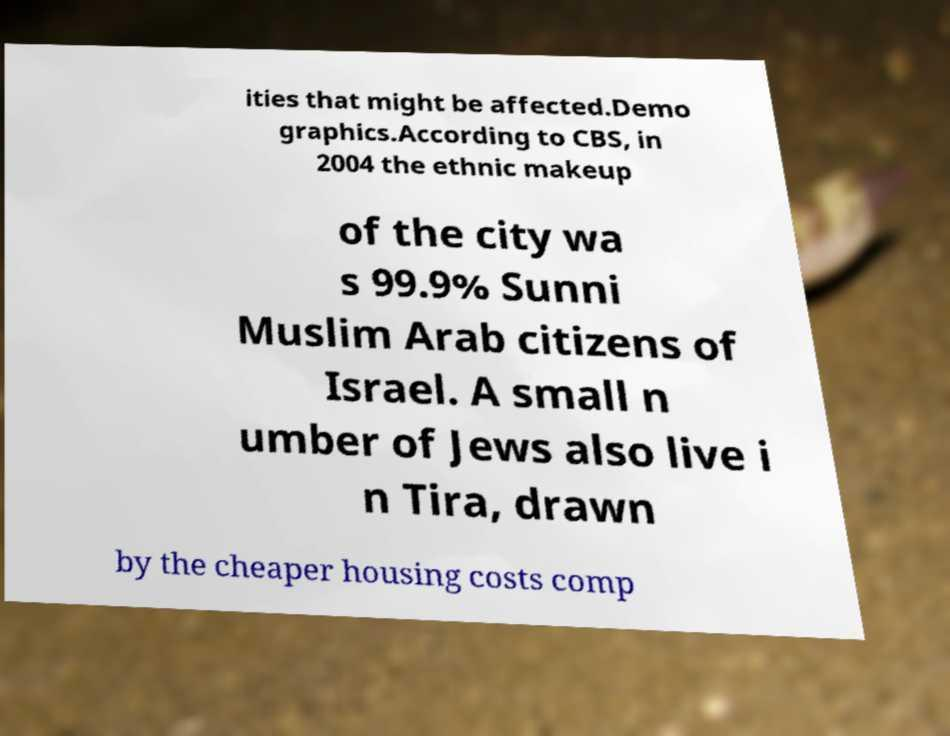What messages or text are displayed in this image? I need them in a readable, typed format. ities that might be affected.Demo graphics.According to CBS, in 2004 the ethnic makeup of the city wa s 99.9% Sunni Muslim Arab citizens of Israel. A small n umber of Jews also live i n Tira, drawn by the cheaper housing costs comp 